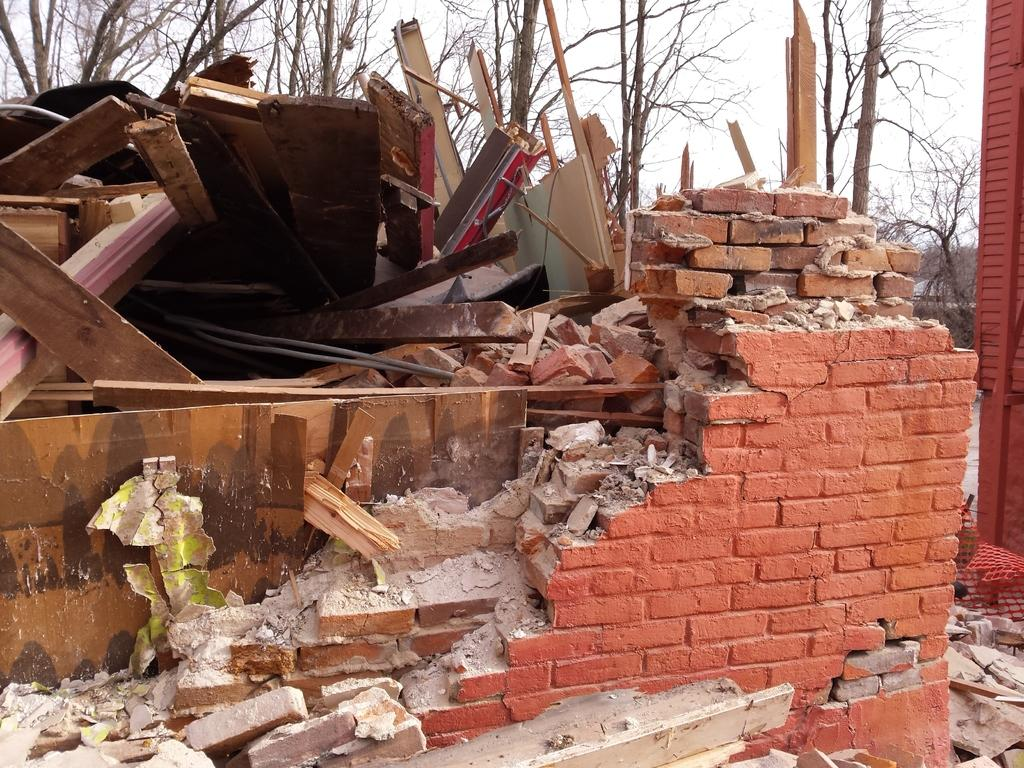What is the main subject of the picture? The main subject of the picture is a dismantled house. What can be seen in the background of the picture? There are trees visible in the picture. How would you describe the weather in the picture? The sky is cloudy in the picture, suggesting a potentially overcast or rainy day. What type of building is being produced in the picture? There is no building being produced in the picture; it features a dismantled house. What rule is being enforced in the picture? There is no rule being enforced in the picture; it shows a dismantled house and trees in a cloudy sky. 